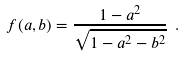<formula> <loc_0><loc_0><loc_500><loc_500>f ( a , b ) = \frac { 1 - a ^ { 2 } } { \sqrt { 1 - a ^ { 2 } - b ^ { 2 } } } \ .</formula> 